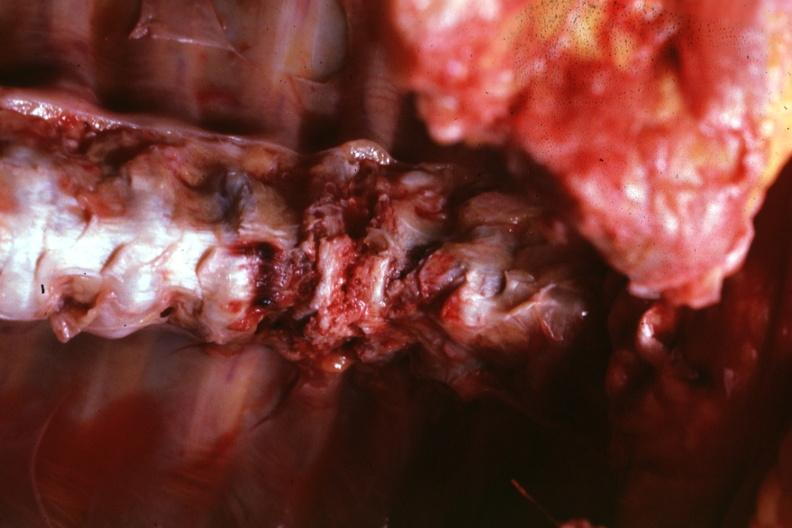s joints present?
Answer the question using a single word or phrase. Yes 